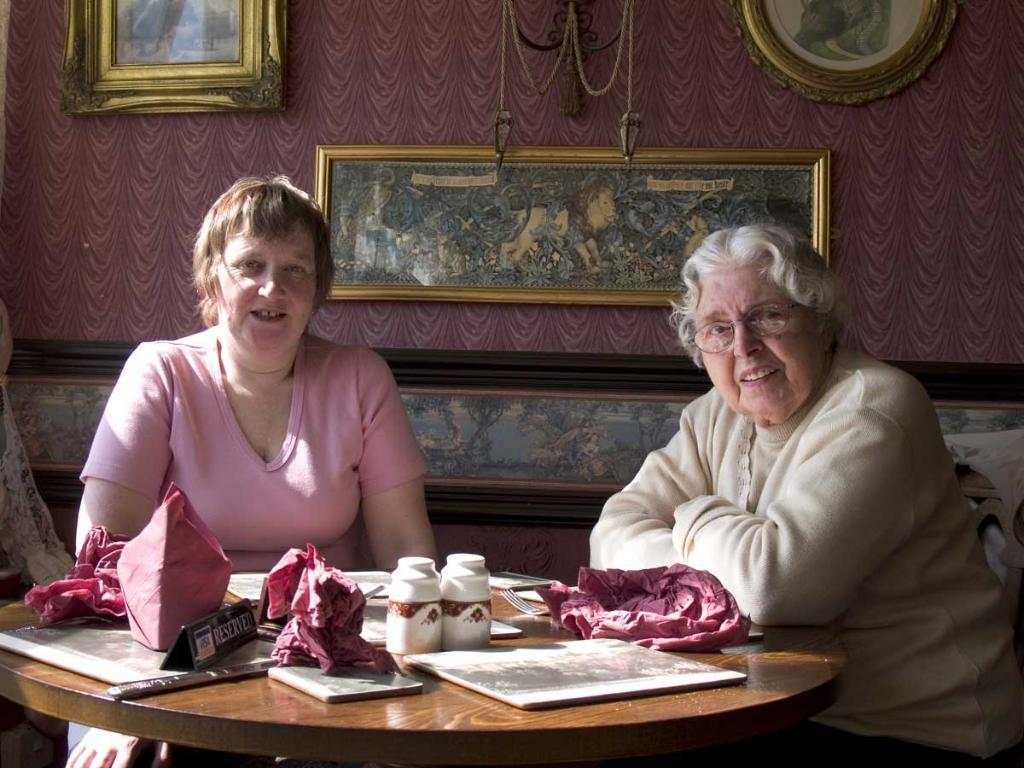How many women are present in the image? There are two women in the image. What objects can be seen alongside the women? There are two bottles in the image. Can you describe the frame in the image? There is a frame in the image. What material is the cloth made of in the image? The cloth in the image is not described in detail, so we cannot determine its material. What is on the table in the image? There is a board on a table in the image. How many frames are attached to the wall in the image? There are three frames attached to a wall in the image. What type of house is depicted in the image? There is no house depicted in the image; it features two women, bottles, a frame, a cloth, a board on a table, and frames on a wall. What type of care is being provided to the women in the image? The image does not show any care being provided to the women; they are simply standing with the other objects. 